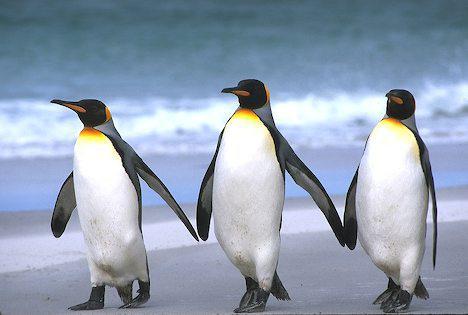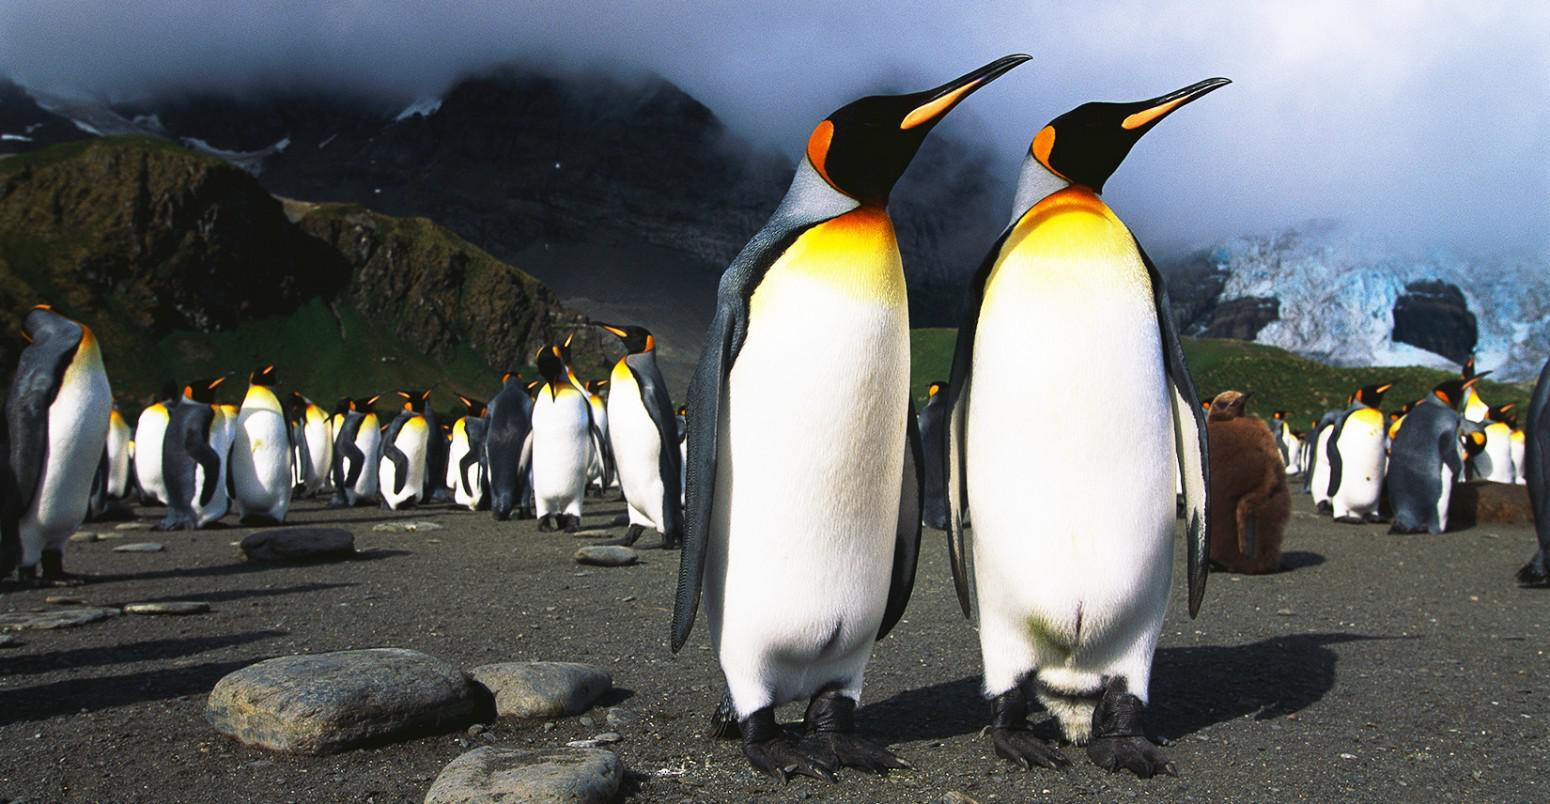The first image is the image on the left, the second image is the image on the right. Given the left and right images, does the statement "Penguins in the left image are walking on ice." hold true? Answer yes or no. No. The first image is the image on the left, the second image is the image on the right. Given the left and right images, does the statement "In at least one of the imagines there is a view of the beach with no more than 3 penguins walking together." hold true? Answer yes or no. Yes. 